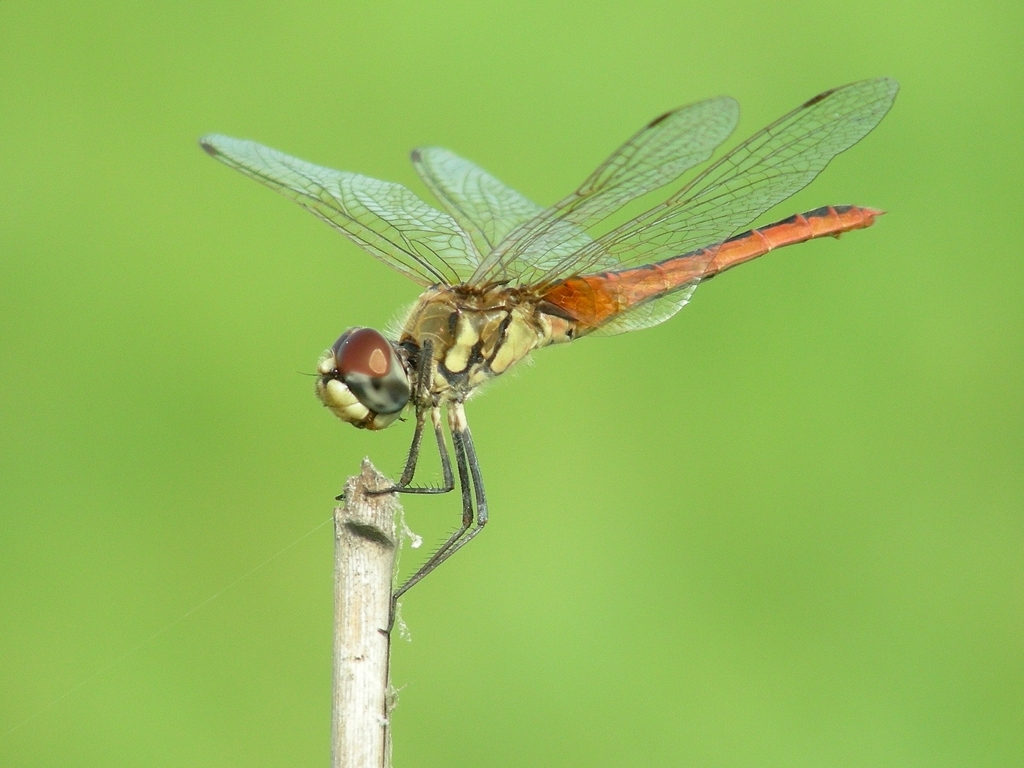Could you comment on the diet and hunting strategies of dragonflies? Dragonflies are skilled hunters, eating a wide variety of insects such as mosquitoes, flies, and moths. They use their exceptional vision and agile flight to catch prey mid-air. Observing their hunting behavior gives us a glimpse into the intricate food webs of ecosystems. 